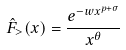<formula> <loc_0><loc_0><loc_500><loc_500>\hat { F } _ { > } ( x ) = \frac { e ^ { - w x ^ { p + \sigma } } } { x ^ { \theta } }</formula> 